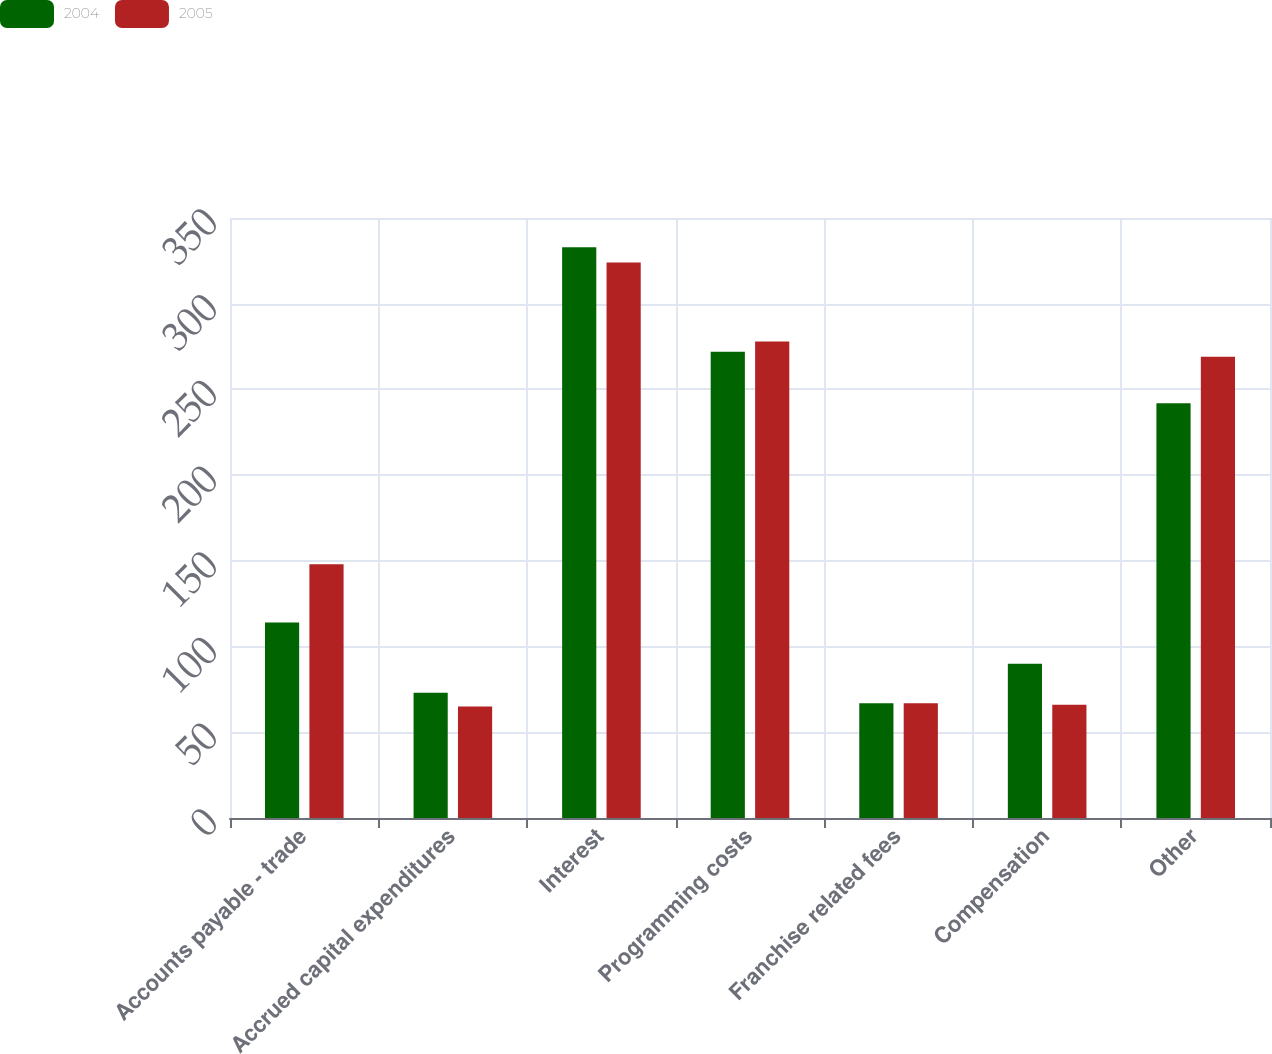Convert chart. <chart><loc_0><loc_0><loc_500><loc_500><stacked_bar_chart><ecel><fcel>Accounts payable - trade<fcel>Accrued capital expenditures<fcel>Interest<fcel>Programming costs<fcel>Franchise related fees<fcel>Compensation<fcel>Other<nl><fcel>2004<fcel>114<fcel>73<fcel>333<fcel>272<fcel>67<fcel>90<fcel>242<nl><fcel>2005<fcel>148<fcel>65<fcel>324<fcel>278<fcel>67<fcel>66<fcel>269<nl></chart> 